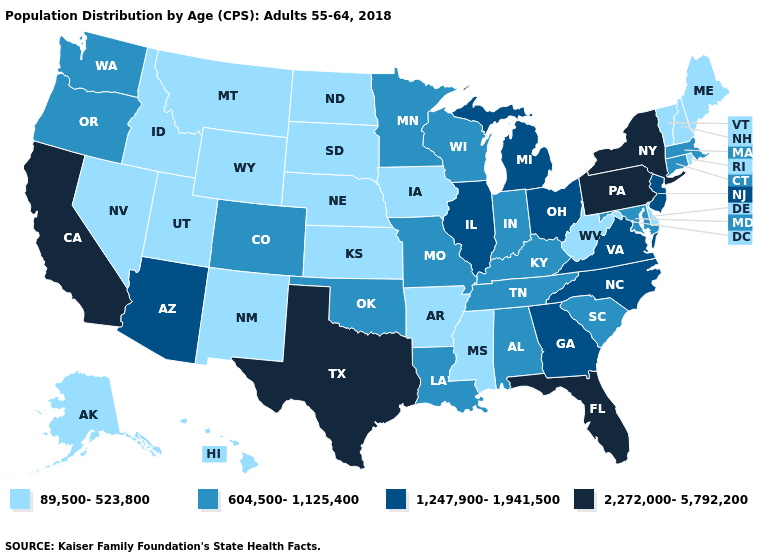What is the value of Oregon?
Be succinct. 604,500-1,125,400. Does Iowa have a lower value than Kansas?
Keep it brief. No. Among the states that border Oklahoma , which have the lowest value?
Be succinct. Arkansas, Kansas, New Mexico. Among the states that border Illinois , does Iowa have the lowest value?
Give a very brief answer. Yes. What is the highest value in the MidWest ?
Short answer required. 1,247,900-1,941,500. Name the states that have a value in the range 89,500-523,800?
Concise answer only. Alaska, Arkansas, Delaware, Hawaii, Idaho, Iowa, Kansas, Maine, Mississippi, Montana, Nebraska, Nevada, New Hampshire, New Mexico, North Dakota, Rhode Island, South Dakota, Utah, Vermont, West Virginia, Wyoming. Does Kentucky have a lower value than Louisiana?
Answer briefly. No. What is the value of New Hampshire?
Short answer required. 89,500-523,800. What is the lowest value in the South?
Concise answer only. 89,500-523,800. Name the states that have a value in the range 604,500-1,125,400?
Give a very brief answer. Alabama, Colorado, Connecticut, Indiana, Kentucky, Louisiana, Maryland, Massachusetts, Minnesota, Missouri, Oklahoma, Oregon, South Carolina, Tennessee, Washington, Wisconsin. What is the value of Illinois?
Keep it brief. 1,247,900-1,941,500. Does the map have missing data?
Concise answer only. No. What is the lowest value in states that border Kentucky?
Concise answer only. 89,500-523,800. Is the legend a continuous bar?
Short answer required. No. 